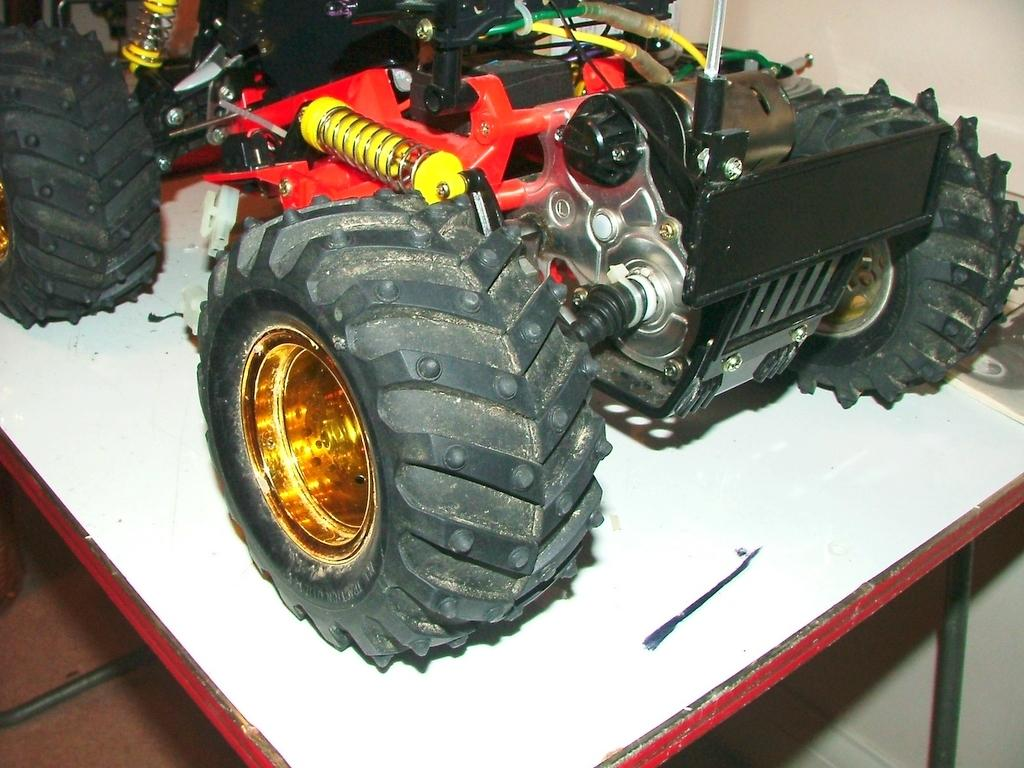What is the main subject of the image? The main subject of the image is a miniature tractor. Where is the miniature tractor located in the image? The miniature tractor is on a table. What type of tax is being discussed in the image? There is no discussion of tax in the image; it features a miniature tractor on a table. What memory is being triggered by the miniature tractor in the image? There is no indication of a memory being triggered by the miniature tractor in the image. 